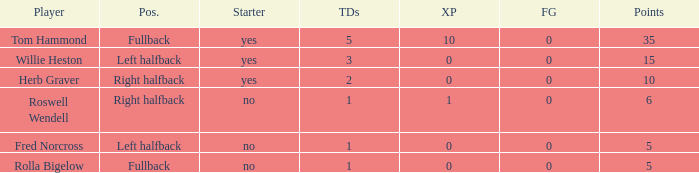How many more points did roswell wendell, the right halfback, accumulate? 1.0. 